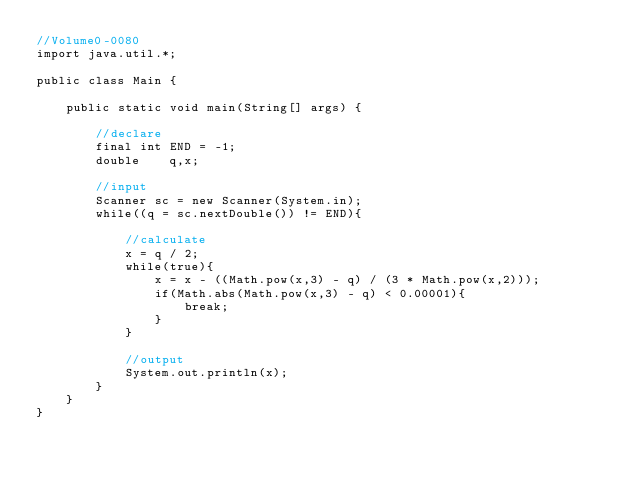Convert code to text. <code><loc_0><loc_0><loc_500><loc_500><_Java_>//Volume0-0080
import java.util.*;

public class Main {

	public static void main(String[] args) {

		//declare
		final int END = -1;
		double    q,x;

		//input
		Scanner sc = new Scanner(System.in);
		while((q = sc.nextDouble()) != END){
			
			//calculate
			x = q / 2;
			while(true){
				x = x - ((Math.pow(x,3) - q) / (3 * Math.pow(x,2)));
				if(Math.abs(Math.pow(x,3) - q) < 0.00001){
					break;
				}
			}
			
			//output
			System.out.println(x);
		}
	}
}</code> 